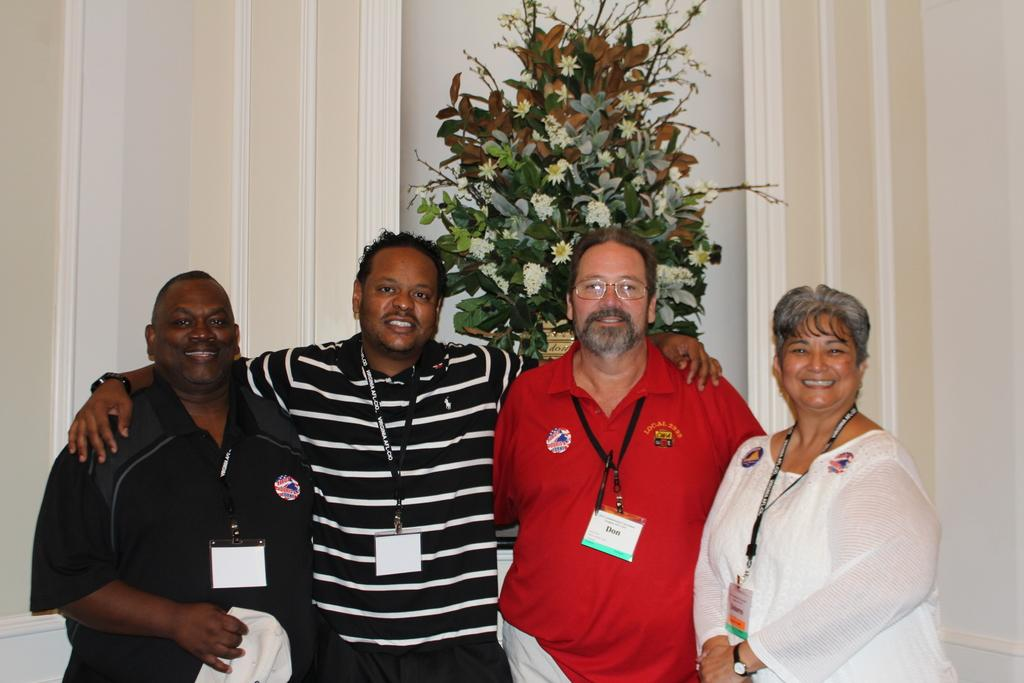How many people are in the image? There is a group of persons in the image. What are the persons in the image doing? The persons are smiling. Where are the persons standing in the image? The persons are standing on the floor. What can be seen in the background of the image? There is a pot plant with flowers and a white wall in the background of the image. What type of polish is being applied to the yard in the image? There is no mention of polish or a yard in the image; it features a group of persons standing and smiling. 